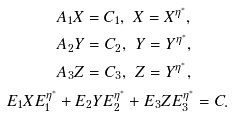Convert formula to latex. <formula><loc_0><loc_0><loc_500><loc_500>& A _ { 1 } X = C _ { 1 } , \ X = X ^ { \eta ^ { \ast } } , \\ & A _ { 2 } Y = C _ { 2 } , \ Y = Y ^ { \eta ^ { \ast } } , \\ & A _ { 3 } Z = C _ { 3 } , \ Z = Y ^ { \eta ^ { \ast } } , \\ E _ { 1 } X E _ { 1 } ^ { \eta ^ { \ast } } & + E _ { 2 } Y E _ { 2 } ^ { \eta ^ { \ast } } + E _ { 3 } Z E _ { 3 } ^ { \eta ^ { \ast } } = C .</formula> 